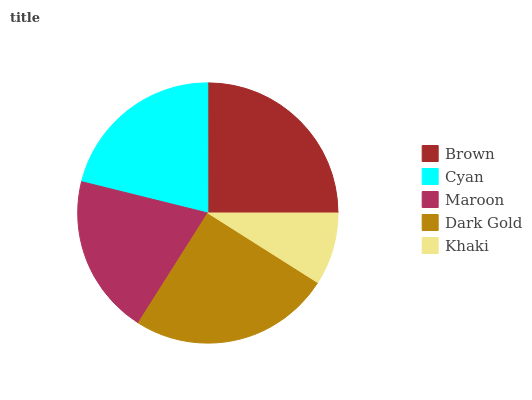Is Khaki the minimum?
Answer yes or no. Yes. Is Brown the maximum?
Answer yes or no. Yes. Is Cyan the minimum?
Answer yes or no. No. Is Cyan the maximum?
Answer yes or no. No. Is Brown greater than Cyan?
Answer yes or no. Yes. Is Cyan less than Brown?
Answer yes or no. Yes. Is Cyan greater than Brown?
Answer yes or no. No. Is Brown less than Cyan?
Answer yes or no. No. Is Cyan the high median?
Answer yes or no. Yes. Is Cyan the low median?
Answer yes or no. Yes. Is Maroon the high median?
Answer yes or no. No. Is Khaki the low median?
Answer yes or no. No. 